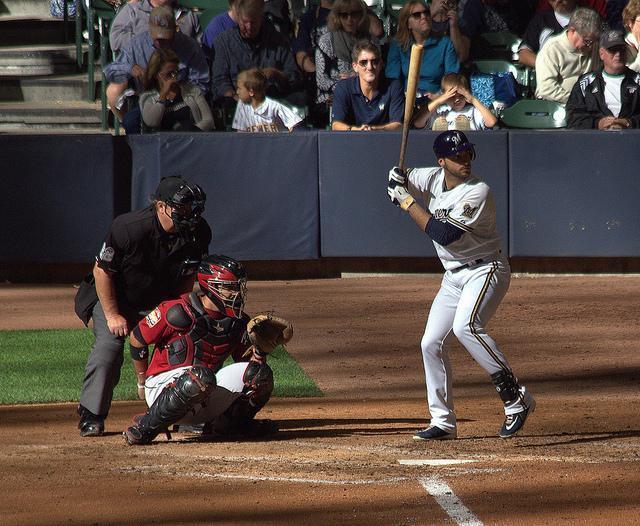How many people are visible?
Give a very brief answer. 12. How many chairs don't have a dog on them?
Give a very brief answer. 0. 